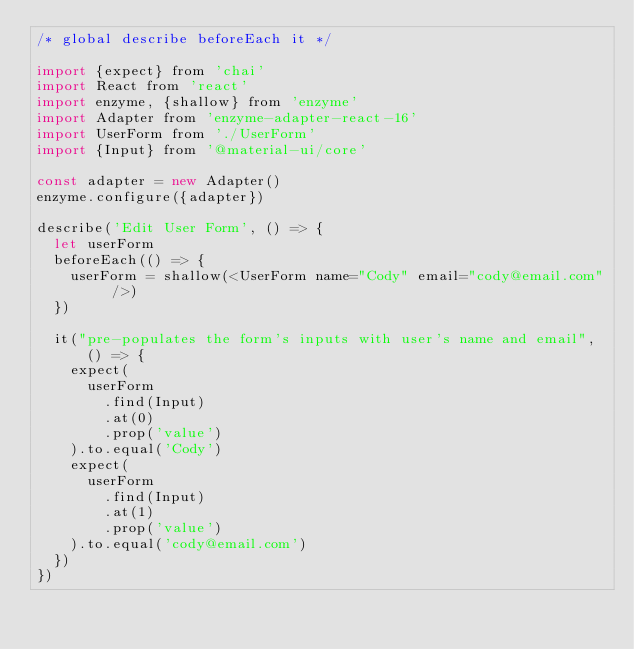Convert code to text. <code><loc_0><loc_0><loc_500><loc_500><_JavaScript_>/* global describe beforeEach it */

import {expect} from 'chai'
import React from 'react'
import enzyme, {shallow} from 'enzyme'
import Adapter from 'enzyme-adapter-react-16'
import UserForm from './UserForm'
import {Input} from '@material-ui/core'

const adapter = new Adapter()
enzyme.configure({adapter})

describe('Edit User Form', () => {
  let userForm
  beforeEach(() => {
    userForm = shallow(<UserForm name="Cody" email="cody@email.com" />)
  })

  it("pre-populates the form's inputs with user's name and email", () => {
    expect(
      userForm
        .find(Input)
        .at(0)
        .prop('value')
    ).to.equal('Cody')
    expect(
      userForm
        .find(Input)
        .at(1)
        .prop('value')
    ).to.equal('cody@email.com')
  })
})
</code> 